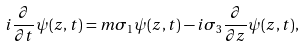Convert formula to latex. <formula><loc_0><loc_0><loc_500><loc_500>i \frac { \partial } { \partial t } \psi ( z , t ) = m \sigma _ { 1 } \psi ( z , t ) - i \sigma _ { 3 } \frac { \partial } { \partial z } \psi ( z , t ) ,</formula> 